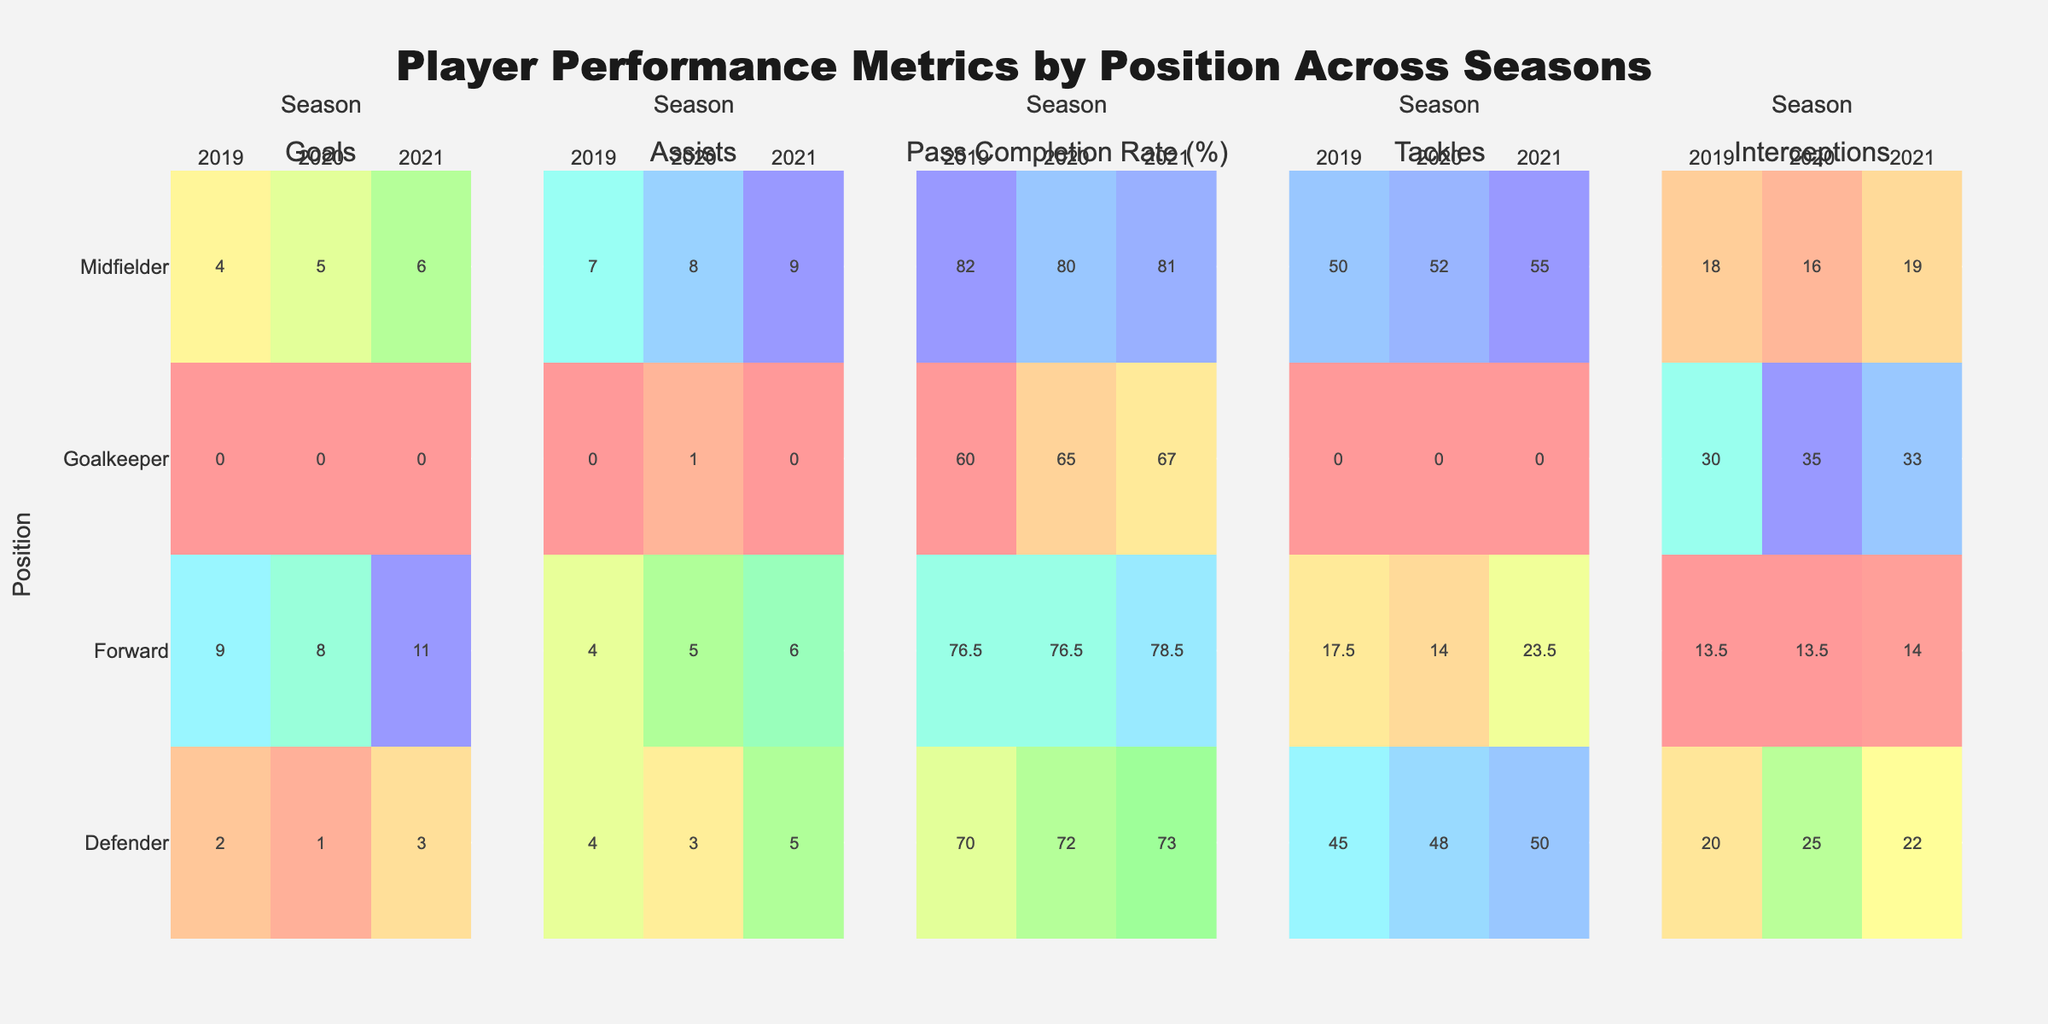What is the title of the figure? The title of the figure is usually located at the top, in a larger font size compared to other textual elements. For this figure, you can see the title "Player Performance Metrics by Position Across Seasons" clearly stated at the top.
Answer: Player Performance Metrics by Position Across Seasons How many different player positions are depicted across the seasons? To answer this, you need to look at the y-axis, which indicates player positions. The positions listed are Forward, Goalkeeper, Defender, and Midfielder.
Answer: 4 In which metric did Goalkeepers have the highest average value across all seasons? Observing the heatmaps, particularly focusing on the rows labeled 'Goalkeeper', we see that the 'Interceptions' column has the highest intensity (color). The numerical values would confirm if checked.
Answer: Interceptions Which season had the highest average Goals for Forwards? By examining the heatmap under 'Goals' for the Forward position across different seasons, we see that the cell corresponding to the 2021 season has the brightest color intensity, indicating the highest average.
Answer: 2021 What is the trend of Pass Completion Rate (%) for Midfielders from 2019 to 2021? Looking at the heatmap for Pass Completion Rate (%) and focusing on the rows labeled 'Midfielder', we can see the gradient of the cell colors from 2019 to 2021. The intensity of the cells suggests that the Pass Completion Rate (%) increased over these seasons.
Answer: Increasing trend Compare the average number of Assists between Defenders and Midfielders in the 2020 season. Checking the heatmap under 'Assists' for the 2020 season, we compare the intensities for Defenders and Midfielders. The cell color intensity indicates that Midfielders had a higher average number of Assists than Defenders.
Answer: Midfielders had more Assists Which position had the lowest average value in the Tackles metric in the 2020 season? Observing the 'Tackles' heatmap, we look for the lowest color intensity under the 2020 season. The position with the least intensity in this column is again the Goalkeeper.
Answer: Goalkeeper How does the average number of Interceptions for Forwards compare between 2019 and 2021? To compare, we look at the 'Interceptions' heatmap under the Forward position for both 2019 and 2021. The color intensity and numerical values indicate a decrease from 15 in 2019 to 14 in 2021.
Answer: Decreased What is the general pattern of total tackles made by Defenders from 2019 through 2021? To identify the pattern, view the color intensity under 'Tackles' for the Defender position across the three years. The consistent high intensity suggests that Defenders maintained a high number of tackles across all seasons.
Answer: Consistently high 